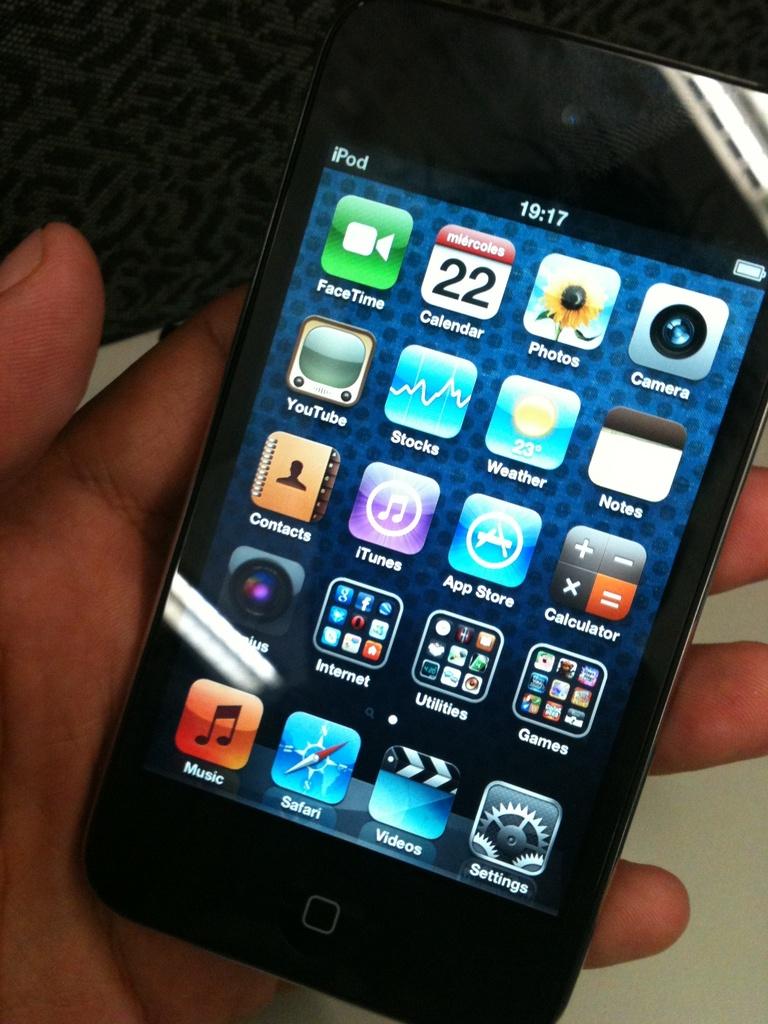What time is displayed on the phone on the right?
Offer a very short reply. 19:17. What is the name of this electronic device?
Provide a succinct answer. Ipod. 